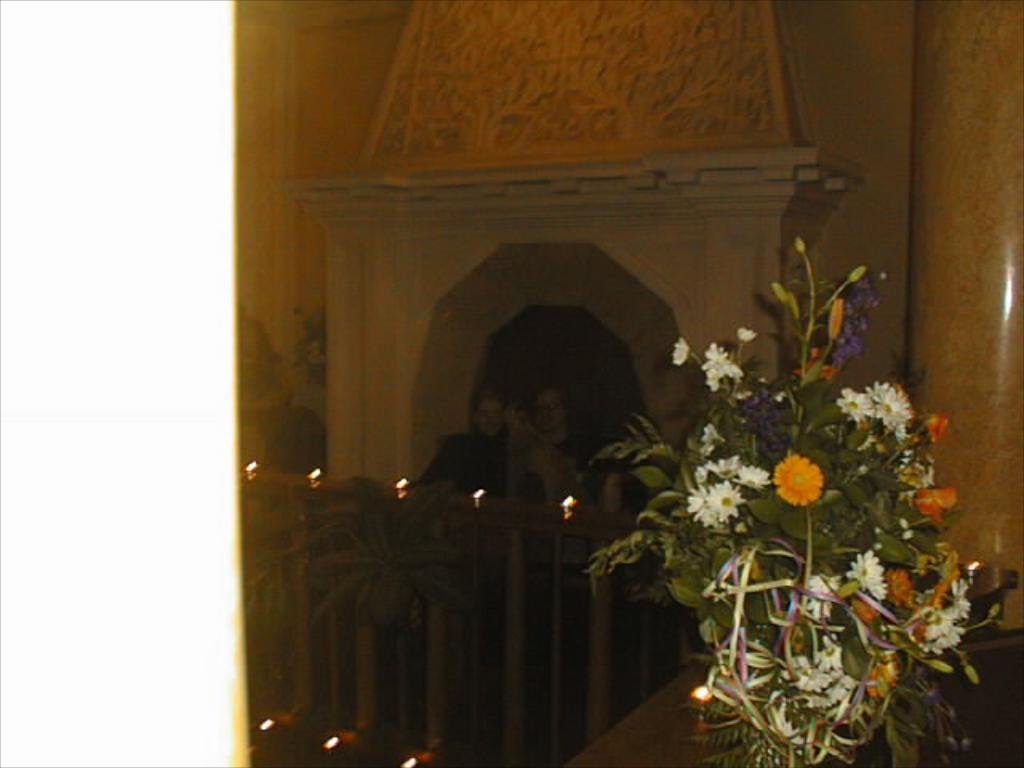What is the main object in the image? There is a bouquet in the image. Where is the bouquet placed? The bouquet is placed on a surface. What architectural feature can be seen in the image? There is railing visible in the image. What type of illumination is present in the image? There are lights in the image. What type of plant is visible in the image? There is a plant in the image. What structural element can be seen in the image? There is a pillar in the image. What are the people in the image doing? There are people standing beside a wall in the image. What type of bone can be seen in the image? There is no bone present in the image. What does the bouquet smell like in the image? The image does not provide information about the scent of the bouquet. 